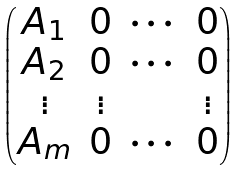Convert formula to latex. <formula><loc_0><loc_0><loc_500><loc_500>\begin{pmatrix} A _ { 1 } & 0 & \cdots & 0 \\ A _ { 2 } & 0 & \cdots & 0 \\ \vdots & \vdots & & \vdots \\ A _ { m } & 0 & \cdots & 0 \end{pmatrix}</formula> 